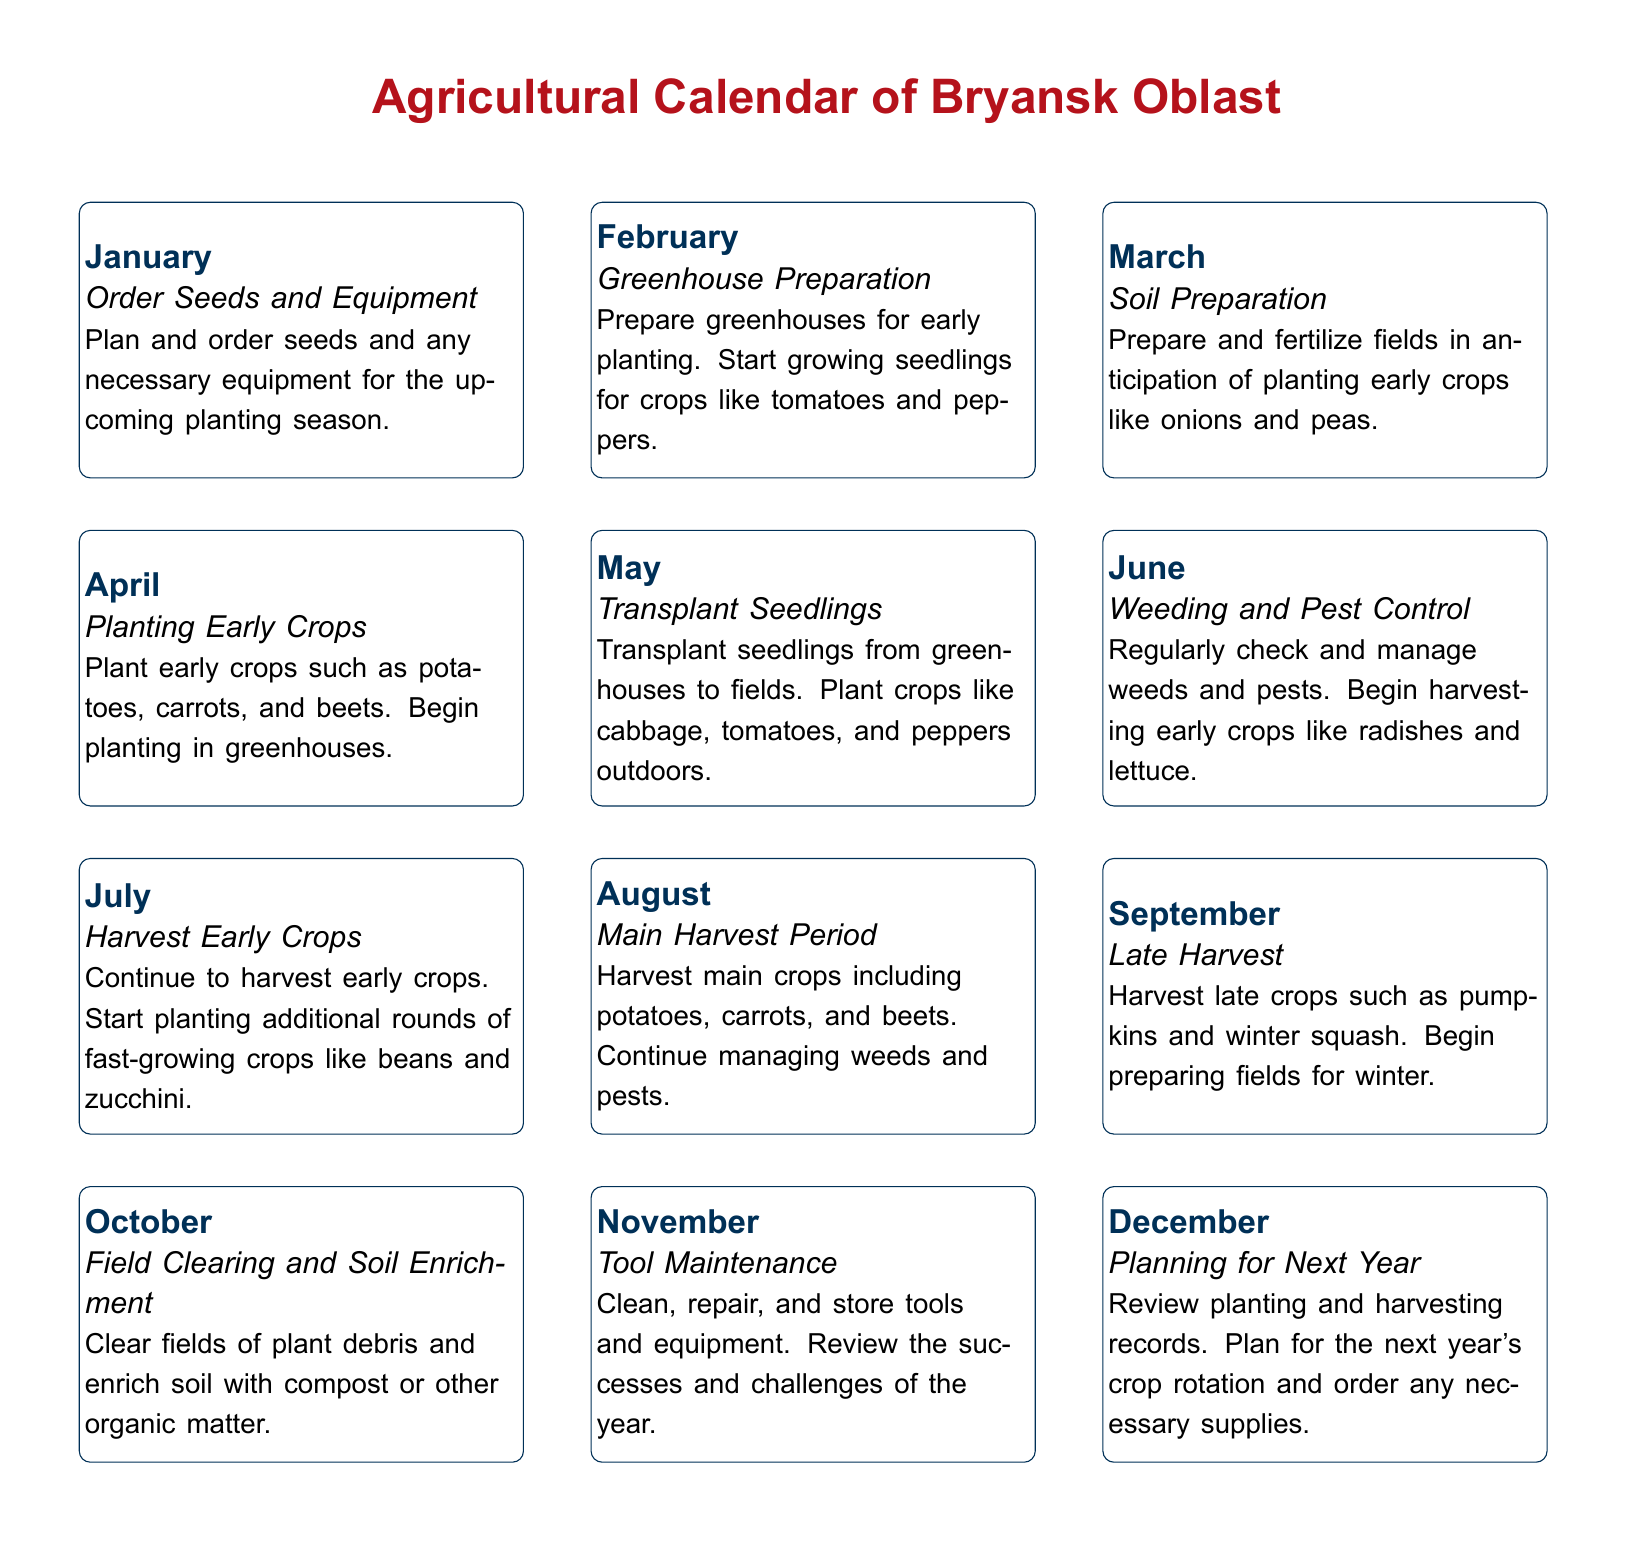What activities are planned for January? January focuses on ordering seeds and equipment.
Answer: Order Seeds and Equipment What crops are transplanted in May? In May, seedlings are transplanted and crops like cabbage, tomatoes, and peppers are planted outdoors.
Answer: Cabbage, tomatoes, and peppers Which month is designated for weeding and pest control? June is specifically mentioned for regular weeding and pest control activities.
Answer: June What is the main focus of October? In October, the primary activity is clearing fields and enriching the soil.
Answer: Field Clearing and Soil Enrichment How many harvest periods are mentioned? The document outlines three specific harvest periods throughout the year.
Answer: Three What follows the main harvest period in August? September is designated for late harvest activities.
Answer: Late Harvest Which month is associated with tool maintenance? November is when tool maintenance is emphasized in the calendar.
Answer: November What is the last activity mentioned for the year? The final activity listed in the calendar for the year is planning for next year.
Answer: Planning for Next Year 